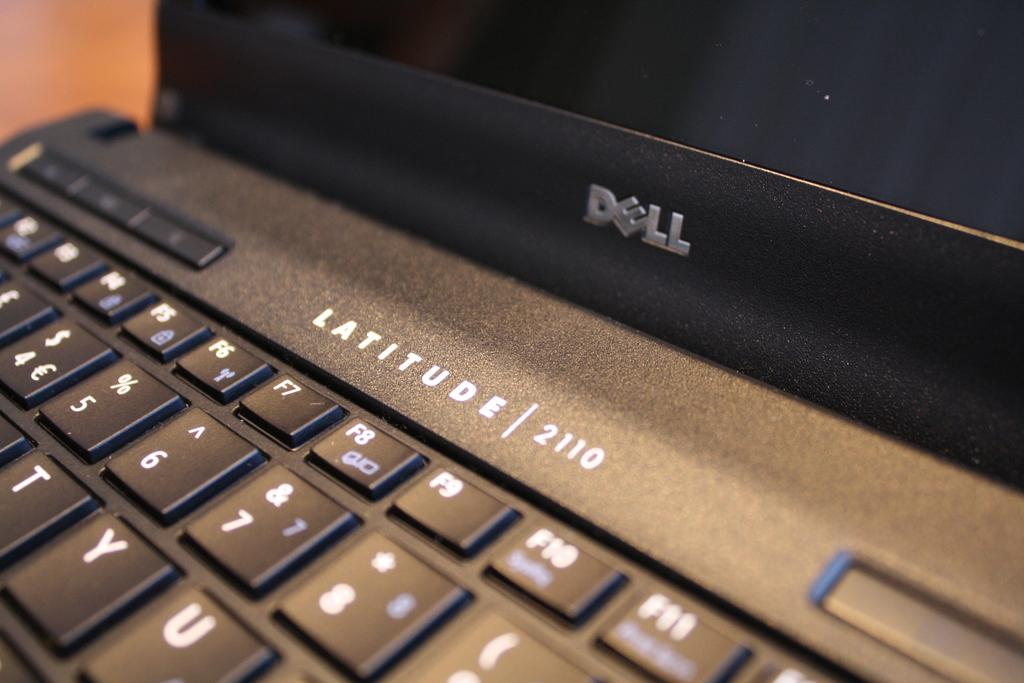Provide a one-sentence caption for the provided image. A close up of a black Dell Latitude laptop. 